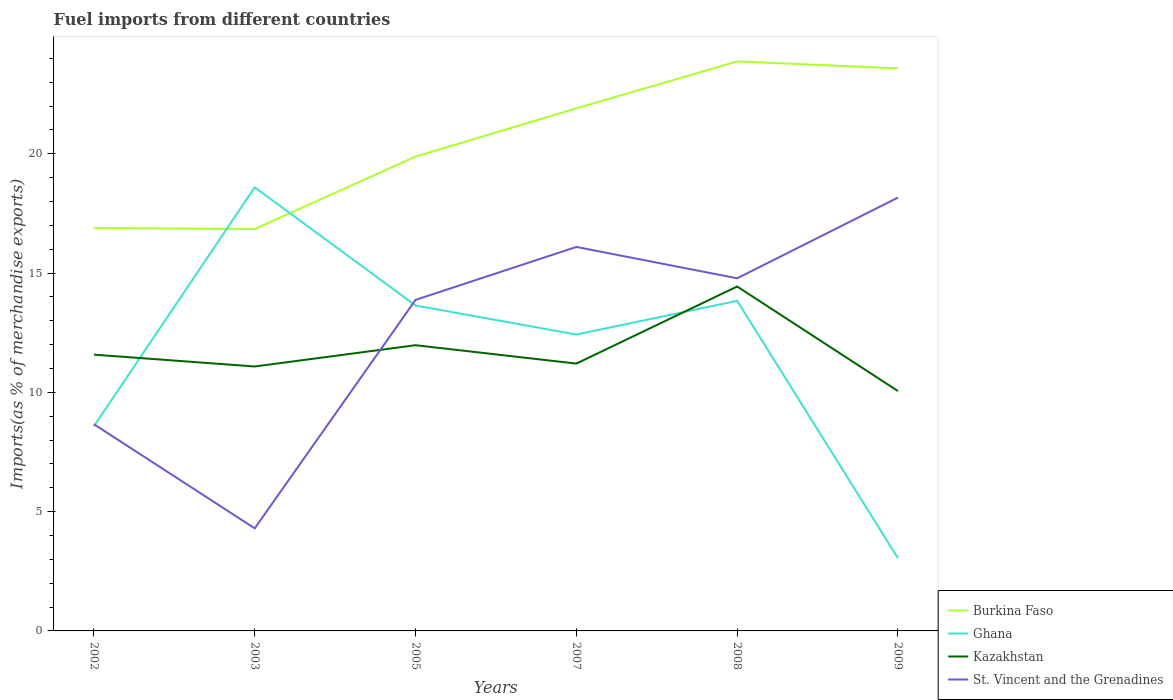Is the number of lines equal to the number of legend labels?
Give a very brief answer. Yes. Across all years, what is the maximum percentage of imports to different countries in St. Vincent and the Grenadines?
Provide a short and direct response. 4.3. In which year was the percentage of imports to different countries in Ghana maximum?
Provide a short and direct response. 2009. What is the total percentage of imports to different countries in Burkina Faso in the graph?
Your answer should be very brief. -6.73. What is the difference between the highest and the second highest percentage of imports to different countries in Burkina Faso?
Your answer should be very brief. 7.03. Is the percentage of imports to different countries in Kazakhstan strictly greater than the percentage of imports to different countries in Ghana over the years?
Give a very brief answer. No. What is the difference between two consecutive major ticks on the Y-axis?
Your answer should be compact. 5. Are the values on the major ticks of Y-axis written in scientific E-notation?
Offer a very short reply. No. Where does the legend appear in the graph?
Keep it short and to the point. Bottom right. How many legend labels are there?
Your response must be concise. 4. How are the legend labels stacked?
Your response must be concise. Vertical. What is the title of the graph?
Keep it short and to the point. Fuel imports from different countries. What is the label or title of the X-axis?
Give a very brief answer. Years. What is the label or title of the Y-axis?
Offer a terse response. Imports(as % of merchandise exports). What is the Imports(as % of merchandise exports) of Burkina Faso in 2002?
Give a very brief answer. 16.89. What is the Imports(as % of merchandise exports) in Ghana in 2002?
Your answer should be very brief. 8.58. What is the Imports(as % of merchandise exports) of Kazakhstan in 2002?
Your answer should be very brief. 11.58. What is the Imports(as % of merchandise exports) in St. Vincent and the Grenadines in 2002?
Provide a short and direct response. 8.67. What is the Imports(as % of merchandise exports) of Burkina Faso in 2003?
Make the answer very short. 16.85. What is the Imports(as % of merchandise exports) of Ghana in 2003?
Your answer should be compact. 18.6. What is the Imports(as % of merchandise exports) in Kazakhstan in 2003?
Make the answer very short. 11.09. What is the Imports(as % of merchandise exports) in St. Vincent and the Grenadines in 2003?
Provide a short and direct response. 4.3. What is the Imports(as % of merchandise exports) in Burkina Faso in 2005?
Your answer should be compact. 19.88. What is the Imports(as % of merchandise exports) of Ghana in 2005?
Give a very brief answer. 13.64. What is the Imports(as % of merchandise exports) in Kazakhstan in 2005?
Keep it short and to the point. 11.98. What is the Imports(as % of merchandise exports) of St. Vincent and the Grenadines in 2005?
Your response must be concise. 13.88. What is the Imports(as % of merchandise exports) of Burkina Faso in 2007?
Provide a short and direct response. 21.91. What is the Imports(as % of merchandise exports) in Ghana in 2007?
Offer a terse response. 12.43. What is the Imports(as % of merchandise exports) in Kazakhstan in 2007?
Make the answer very short. 11.21. What is the Imports(as % of merchandise exports) of St. Vincent and the Grenadines in 2007?
Your answer should be very brief. 16.1. What is the Imports(as % of merchandise exports) in Burkina Faso in 2008?
Make the answer very short. 23.87. What is the Imports(as % of merchandise exports) in Ghana in 2008?
Keep it short and to the point. 13.84. What is the Imports(as % of merchandise exports) of Kazakhstan in 2008?
Provide a succinct answer. 14.44. What is the Imports(as % of merchandise exports) of St. Vincent and the Grenadines in 2008?
Keep it short and to the point. 14.78. What is the Imports(as % of merchandise exports) in Burkina Faso in 2009?
Your answer should be very brief. 23.58. What is the Imports(as % of merchandise exports) in Ghana in 2009?
Ensure brevity in your answer.  3.05. What is the Imports(as % of merchandise exports) of Kazakhstan in 2009?
Provide a short and direct response. 10.06. What is the Imports(as % of merchandise exports) of St. Vincent and the Grenadines in 2009?
Give a very brief answer. 18.17. Across all years, what is the maximum Imports(as % of merchandise exports) in Burkina Faso?
Ensure brevity in your answer.  23.87. Across all years, what is the maximum Imports(as % of merchandise exports) of Ghana?
Provide a short and direct response. 18.6. Across all years, what is the maximum Imports(as % of merchandise exports) in Kazakhstan?
Give a very brief answer. 14.44. Across all years, what is the maximum Imports(as % of merchandise exports) of St. Vincent and the Grenadines?
Provide a short and direct response. 18.17. Across all years, what is the minimum Imports(as % of merchandise exports) in Burkina Faso?
Your answer should be very brief. 16.85. Across all years, what is the minimum Imports(as % of merchandise exports) of Ghana?
Offer a very short reply. 3.05. Across all years, what is the minimum Imports(as % of merchandise exports) in Kazakhstan?
Give a very brief answer. 10.06. Across all years, what is the minimum Imports(as % of merchandise exports) of St. Vincent and the Grenadines?
Your answer should be very brief. 4.3. What is the total Imports(as % of merchandise exports) in Burkina Faso in the graph?
Your response must be concise. 122.99. What is the total Imports(as % of merchandise exports) of Ghana in the graph?
Your answer should be compact. 70.13. What is the total Imports(as % of merchandise exports) of Kazakhstan in the graph?
Make the answer very short. 70.35. What is the total Imports(as % of merchandise exports) of St. Vincent and the Grenadines in the graph?
Give a very brief answer. 75.89. What is the difference between the Imports(as % of merchandise exports) of Burkina Faso in 2002 and that in 2003?
Your response must be concise. 0.04. What is the difference between the Imports(as % of merchandise exports) of Ghana in 2002 and that in 2003?
Keep it short and to the point. -10.01. What is the difference between the Imports(as % of merchandise exports) of Kazakhstan in 2002 and that in 2003?
Offer a very short reply. 0.5. What is the difference between the Imports(as % of merchandise exports) in St. Vincent and the Grenadines in 2002 and that in 2003?
Make the answer very short. 4.37. What is the difference between the Imports(as % of merchandise exports) in Burkina Faso in 2002 and that in 2005?
Ensure brevity in your answer.  -2.99. What is the difference between the Imports(as % of merchandise exports) in Ghana in 2002 and that in 2005?
Your answer should be very brief. -5.06. What is the difference between the Imports(as % of merchandise exports) of Kazakhstan in 2002 and that in 2005?
Provide a succinct answer. -0.4. What is the difference between the Imports(as % of merchandise exports) of St. Vincent and the Grenadines in 2002 and that in 2005?
Your response must be concise. -5.21. What is the difference between the Imports(as % of merchandise exports) of Burkina Faso in 2002 and that in 2007?
Your response must be concise. -5.02. What is the difference between the Imports(as % of merchandise exports) in Ghana in 2002 and that in 2007?
Keep it short and to the point. -3.84. What is the difference between the Imports(as % of merchandise exports) of Kazakhstan in 2002 and that in 2007?
Your answer should be compact. 0.38. What is the difference between the Imports(as % of merchandise exports) in St. Vincent and the Grenadines in 2002 and that in 2007?
Your response must be concise. -7.43. What is the difference between the Imports(as % of merchandise exports) in Burkina Faso in 2002 and that in 2008?
Offer a terse response. -6.98. What is the difference between the Imports(as % of merchandise exports) in Ghana in 2002 and that in 2008?
Keep it short and to the point. -5.26. What is the difference between the Imports(as % of merchandise exports) in Kazakhstan in 2002 and that in 2008?
Offer a very short reply. -2.86. What is the difference between the Imports(as % of merchandise exports) of St. Vincent and the Grenadines in 2002 and that in 2008?
Ensure brevity in your answer.  -6.12. What is the difference between the Imports(as % of merchandise exports) in Burkina Faso in 2002 and that in 2009?
Provide a succinct answer. -6.69. What is the difference between the Imports(as % of merchandise exports) of Ghana in 2002 and that in 2009?
Your answer should be compact. 5.53. What is the difference between the Imports(as % of merchandise exports) in Kazakhstan in 2002 and that in 2009?
Offer a terse response. 1.53. What is the difference between the Imports(as % of merchandise exports) of St. Vincent and the Grenadines in 2002 and that in 2009?
Offer a very short reply. -9.5. What is the difference between the Imports(as % of merchandise exports) of Burkina Faso in 2003 and that in 2005?
Your answer should be compact. -3.04. What is the difference between the Imports(as % of merchandise exports) of Ghana in 2003 and that in 2005?
Give a very brief answer. 4.95. What is the difference between the Imports(as % of merchandise exports) in Kazakhstan in 2003 and that in 2005?
Keep it short and to the point. -0.89. What is the difference between the Imports(as % of merchandise exports) in St. Vincent and the Grenadines in 2003 and that in 2005?
Offer a very short reply. -9.58. What is the difference between the Imports(as % of merchandise exports) of Burkina Faso in 2003 and that in 2007?
Provide a short and direct response. -5.06. What is the difference between the Imports(as % of merchandise exports) in Ghana in 2003 and that in 2007?
Provide a succinct answer. 6.17. What is the difference between the Imports(as % of merchandise exports) in Kazakhstan in 2003 and that in 2007?
Keep it short and to the point. -0.12. What is the difference between the Imports(as % of merchandise exports) in St. Vincent and the Grenadines in 2003 and that in 2007?
Provide a short and direct response. -11.8. What is the difference between the Imports(as % of merchandise exports) in Burkina Faso in 2003 and that in 2008?
Your answer should be compact. -7.03. What is the difference between the Imports(as % of merchandise exports) in Ghana in 2003 and that in 2008?
Provide a succinct answer. 4.76. What is the difference between the Imports(as % of merchandise exports) of Kazakhstan in 2003 and that in 2008?
Offer a terse response. -3.35. What is the difference between the Imports(as % of merchandise exports) in St. Vincent and the Grenadines in 2003 and that in 2008?
Make the answer very short. -10.48. What is the difference between the Imports(as % of merchandise exports) in Burkina Faso in 2003 and that in 2009?
Keep it short and to the point. -6.73. What is the difference between the Imports(as % of merchandise exports) of Ghana in 2003 and that in 2009?
Ensure brevity in your answer.  15.55. What is the difference between the Imports(as % of merchandise exports) in Kazakhstan in 2003 and that in 2009?
Make the answer very short. 1.03. What is the difference between the Imports(as % of merchandise exports) of St. Vincent and the Grenadines in 2003 and that in 2009?
Offer a very short reply. -13.87. What is the difference between the Imports(as % of merchandise exports) of Burkina Faso in 2005 and that in 2007?
Ensure brevity in your answer.  -2.02. What is the difference between the Imports(as % of merchandise exports) in Ghana in 2005 and that in 2007?
Make the answer very short. 1.22. What is the difference between the Imports(as % of merchandise exports) in Kazakhstan in 2005 and that in 2007?
Make the answer very short. 0.77. What is the difference between the Imports(as % of merchandise exports) in St. Vincent and the Grenadines in 2005 and that in 2007?
Provide a succinct answer. -2.22. What is the difference between the Imports(as % of merchandise exports) of Burkina Faso in 2005 and that in 2008?
Provide a short and direct response. -3.99. What is the difference between the Imports(as % of merchandise exports) of Ghana in 2005 and that in 2008?
Keep it short and to the point. -0.19. What is the difference between the Imports(as % of merchandise exports) of Kazakhstan in 2005 and that in 2008?
Ensure brevity in your answer.  -2.46. What is the difference between the Imports(as % of merchandise exports) of St. Vincent and the Grenadines in 2005 and that in 2008?
Keep it short and to the point. -0.91. What is the difference between the Imports(as % of merchandise exports) in Burkina Faso in 2005 and that in 2009?
Provide a short and direct response. -3.7. What is the difference between the Imports(as % of merchandise exports) in Ghana in 2005 and that in 2009?
Your answer should be very brief. 10.6. What is the difference between the Imports(as % of merchandise exports) in Kazakhstan in 2005 and that in 2009?
Ensure brevity in your answer.  1.92. What is the difference between the Imports(as % of merchandise exports) in St. Vincent and the Grenadines in 2005 and that in 2009?
Provide a succinct answer. -4.29. What is the difference between the Imports(as % of merchandise exports) of Burkina Faso in 2007 and that in 2008?
Keep it short and to the point. -1.97. What is the difference between the Imports(as % of merchandise exports) in Ghana in 2007 and that in 2008?
Make the answer very short. -1.41. What is the difference between the Imports(as % of merchandise exports) in Kazakhstan in 2007 and that in 2008?
Give a very brief answer. -3.23. What is the difference between the Imports(as % of merchandise exports) of St. Vincent and the Grenadines in 2007 and that in 2008?
Your response must be concise. 1.31. What is the difference between the Imports(as % of merchandise exports) of Burkina Faso in 2007 and that in 2009?
Provide a short and direct response. -1.68. What is the difference between the Imports(as % of merchandise exports) of Ghana in 2007 and that in 2009?
Make the answer very short. 9.38. What is the difference between the Imports(as % of merchandise exports) of Kazakhstan in 2007 and that in 2009?
Make the answer very short. 1.15. What is the difference between the Imports(as % of merchandise exports) in St. Vincent and the Grenadines in 2007 and that in 2009?
Provide a succinct answer. -2.07. What is the difference between the Imports(as % of merchandise exports) of Burkina Faso in 2008 and that in 2009?
Your answer should be very brief. 0.29. What is the difference between the Imports(as % of merchandise exports) of Ghana in 2008 and that in 2009?
Offer a very short reply. 10.79. What is the difference between the Imports(as % of merchandise exports) in Kazakhstan in 2008 and that in 2009?
Keep it short and to the point. 4.38. What is the difference between the Imports(as % of merchandise exports) of St. Vincent and the Grenadines in 2008 and that in 2009?
Provide a succinct answer. -3.38. What is the difference between the Imports(as % of merchandise exports) of Burkina Faso in 2002 and the Imports(as % of merchandise exports) of Ghana in 2003?
Offer a very short reply. -1.71. What is the difference between the Imports(as % of merchandise exports) of Burkina Faso in 2002 and the Imports(as % of merchandise exports) of Kazakhstan in 2003?
Provide a short and direct response. 5.8. What is the difference between the Imports(as % of merchandise exports) of Burkina Faso in 2002 and the Imports(as % of merchandise exports) of St. Vincent and the Grenadines in 2003?
Make the answer very short. 12.59. What is the difference between the Imports(as % of merchandise exports) in Ghana in 2002 and the Imports(as % of merchandise exports) in Kazakhstan in 2003?
Give a very brief answer. -2.5. What is the difference between the Imports(as % of merchandise exports) of Ghana in 2002 and the Imports(as % of merchandise exports) of St. Vincent and the Grenadines in 2003?
Make the answer very short. 4.28. What is the difference between the Imports(as % of merchandise exports) in Kazakhstan in 2002 and the Imports(as % of merchandise exports) in St. Vincent and the Grenadines in 2003?
Your response must be concise. 7.28. What is the difference between the Imports(as % of merchandise exports) of Burkina Faso in 2002 and the Imports(as % of merchandise exports) of Ghana in 2005?
Offer a very short reply. 3.25. What is the difference between the Imports(as % of merchandise exports) in Burkina Faso in 2002 and the Imports(as % of merchandise exports) in Kazakhstan in 2005?
Offer a very short reply. 4.91. What is the difference between the Imports(as % of merchandise exports) in Burkina Faso in 2002 and the Imports(as % of merchandise exports) in St. Vincent and the Grenadines in 2005?
Make the answer very short. 3.01. What is the difference between the Imports(as % of merchandise exports) in Ghana in 2002 and the Imports(as % of merchandise exports) in Kazakhstan in 2005?
Offer a terse response. -3.4. What is the difference between the Imports(as % of merchandise exports) in Ghana in 2002 and the Imports(as % of merchandise exports) in St. Vincent and the Grenadines in 2005?
Make the answer very short. -5.3. What is the difference between the Imports(as % of merchandise exports) of Kazakhstan in 2002 and the Imports(as % of merchandise exports) of St. Vincent and the Grenadines in 2005?
Your response must be concise. -2.29. What is the difference between the Imports(as % of merchandise exports) of Burkina Faso in 2002 and the Imports(as % of merchandise exports) of Ghana in 2007?
Offer a terse response. 4.47. What is the difference between the Imports(as % of merchandise exports) of Burkina Faso in 2002 and the Imports(as % of merchandise exports) of Kazakhstan in 2007?
Keep it short and to the point. 5.68. What is the difference between the Imports(as % of merchandise exports) of Burkina Faso in 2002 and the Imports(as % of merchandise exports) of St. Vincent and the Grenadines in 2007?
Provide a succinct answer. 0.79. What is the difference between the Imports(as % of merchandise exports) in Ghana in 2002 and the Imports(as % of merchandise exports) in Kazakhstan in 2007?
Give a very brief answer. -2.63. What is the difference between the Imports(as % of merchandise exports) of Ghana in 2002 and the Imports(as % of merchandise exports) of St. Vincent and the Grenadines in 2007?
Your answer should be very brief. -7.52. What is the difference between the Imports(as % of merchandise exports) in Kazakhstan in 2002 and the Imports(as % of merchandise exports) in St. Vincent and the Grenadines in 2007?
Keep it short and to the point. -4.51. What is the difference between the Imports(as % of merchandise exports) in Burkina Faso in 2002 and the Imports(as % of merchandise exports) in Ghana in 2008?
Provide a short and direct response. 3.05. What is the difference between the Imports(as % of merchandise exports) in Burkina Faso in 2002 and the Imports(as % of merchandise exports) in Kazakhstan in 2008?
Keep it short and to the point. 2.45. What is the difference between the Imports(as % of merchandise exports) in Burkina Faso in 2002 and the Imports(as % of merchandise exports) in St. Vincent and the Grenadines in 2008?
Ensure brevity in your answer.  2.11. What is the difference between the Imports(as % of merchandise exports) in Ghana in 2002 and the Imports(as % of merchandise exports) in Kazakhstan in 2008?
Provide a short and direct response. -5.86. What is the difference between the Imports(as % of merchandise exports) of Ghana in 2002 and the Imports(as % of merchandise exports) of St. Vincent and the Grenadines in 2008?
Keep it short and to the point. -6.2. What is the difference between the Imports(as % of merchandise exports) of Kazakhstan in 2002 and the Imports(as % of merchandise exports) of St. Vincent and the Grenadines in 2008?
Offer a terse response. -3.2. What is the difference between the Imports(as % of merchandise exports) of Burkina Faso in 2002 and the Imports(as % of merchandise exports) of Ghana in 2009?
Offer a terse response. 13.84. What is the difference between the Imports(as % of merchandise exports) in Burkina Faso in 2002 and the Imports(as % of merchandise exports) in Kazakhstan in 2009?
Ensure brevity in your answer.  6.83. What is the difference between the Imports(as % of merchandise exports) in Burkina Faso in 2002 and the Imports(as % of merchandise exports) in St. Vincent and the Grenadines in 2009?
Provide a succinct answer. -1.28. What is the difference between the Imports(as % of merchandise exports) in Ghana in 2002 and the Imports(as % of merchandise exports) in Kazakhstan in 2009?
Make the answer very short. -1.47. What is the difference between the Imports(as % of merchandise exports) in Ghana in 2002 and the Imports(as % of merchandise exports) in St. Vincent and the Grenadines in 2009?
Your answer should be very brief. -9.58. What is the difference between the Imports(as % of merchandise exports) in Kazakhstan in 2002 and the Imports(as % of merchandise exports) in St. Vincent and the Grenadines in 2009?
Provide a short and direct response. -6.58. What is the difference between the Imports(as % of merchandise exports) in Burkina Faso in 2003 and the Imports(as % of merchandise exports) in Ghana in 2005?
Your answer should be compact. 3.21. What is the difference between the Imports(as % of merchandise exports) of Burkina Faso in 2003 and the Imports(as % of merchandise exports) of Kazakhstan in 2005?
Your answer should be compact. 4.87. What is the difference between the Imports(as % of merchandise exports) of Burkina Faso in 2003 and the Imports(as % of merchandise exports) of St. Vincent and the Grenadines in 2005?
Offer a very short reply. 2.97. What is the difference between the Imports(as % of merchandise exports) in Ghana in 2003 and the Imports(as % of merchandise exports) in Kazakhstan in 2005?
Offer a terse response. 6.62. What is the difference between the Imports(as % of merchandise exports) of Ghana in 2003 and the Imports(as % of merchandise exports) of St. Vincent and the Grenadines in 2005?
Ensure brevity in your answer.  4.72. What is the difference between the Imports(as % of merchandise exports) in Kazakhstan in 2003 and the Imports(as % of merchandise exports) in St. Vincent and the Grenadines in 2005?
Your response must be concise. -2.79. What is the difference between the Imports(as % of merchandise exports) of Burkina Faso in 2003 and the Imports(as % of merchandise exports) of Ghana in 2007?
Make the answer very short. 4.42. What is the difference between the Imports(as % of merchandise exports) of Burkina Faso in 2003 and the Imports(as % of merchandise exports) of Kazakhstan in 2007?
Your answer should be compact. 5.64. What is the difference between the Imports(as % of merchandise exports) of Burkina Faso in 2003 and the Imports(as % of merchandise exports) of St. Vincent and the Grenadines in 2007?
Ensure brevity in your answer.  0.75. What is the difference between the Imports(as % of merchandise exports) of Ghana in 2003 and the Imports(as % of merchandise exports) of Kazakhstan in 2007?
Ensure brevity in your answer.  7.39. What is the difference between the Imports(as % of merchandise exports) in Ghana in 2003 and the Imports(as % of merchandise exports) in St. Vincent and the Grenadines in 2007?
Your answer should be very brief. 2.5. What is the difference between the Imports(as % of merchandise exports) of Kazakhstan in 2003 and the Imports(as % of merchandise exports) of St. Vincent and the Grenadines in 2007?
Ensure brevity in your answer.  -5.01. What is the difference between the Imports(as % of merchandise exports) of Burkina Faso in 2003 and the Imports(as % of merchandise exports) of Ghana in 2008?
Ensure brevity in your answer.  3.01. What is the difference between the Imports(as % of merchandise exports) of Burkina Faso in 2003 and the Imports(as % of merchandise exports) of Kazakhstan in 2008?
Your answer should be very brief. 2.41. What is the difference between the Imports(as % of merchandise exports) of Burkina Faso in 2003 and the Imports(as % of merchandise exports) of St. Vincent and the Grenadines in 2008?
Offer a terse response. 2.07. What is the difference between the Imports(as % of merchandise exports) in Ghana in 2003 and the Imports(as % of merchandise exports) in Kazakhstan in 2008?
Provide a succinct answer. 4.16. What is the difference between the Imports(as % of merchandise exports) of Ghana in 2003 and the Imports(as % of merchandise exports) of St. Vincent and the Grenadines in 2008?
Your answer should be compact. 3.81. What is the difference between the Imports(as % of merchandise exports) of Kazakhstan in 2003 and the Imports(as % of merchandise exports) of St. Vincent and the Grenadines in 2008?
Ensure brevity in your answer.  -3.7. What is the difference between the Imports(as % of merchandise exports) of Burkina Faso in 2003 and the Imports(as % of merchandise exports) of Ghana in 2009?
Offer a terse response. 13.8. What is the difference between the Imports(as % of merchandise exports) of Burkina Faso in 2003 and the Imports(as % of merchandise exports) of Kazakhstan in 2009?
Provide a short and direct response. 6.79. What is the difference between the Imports(as % of merchandise exports) in Burkina Faso in 2003 and the Imports(as % of merchandise exports) in St. Vincent and the Grenadines in 2009?
Give a very brief answer. -1.32. What is the difference between the Imports(as % of merchandise exports) in Ghana in 2003 and the Imports(as % of merchandise exports) in Kazakhstan in 2009?
Offer a terse response. 8.54. What is the difference between the Imports(as % of merchandise exports) of Ghana in 2003 and the Imports(as % of merchandise exports) of St. Vincent and the Grenadines in 2009?
Provide a short and direct response. 0.43. What is the difference between the Imports(as % of merchandise exports) of Kazakhstan in 2003 and the Imports(as % of merchandise exports) of St. Vincent and the Grenadines in 2009?
Offer a very short reply. -7.08. What is the difference between the Imports(as % of merchandise exports) of Burkina Faso in 2005 and the Imports(as % of merchandise exports) of Ghana in 2007?
Keep it short and to the point. 7.46. What is the difference between the Imports(as % of merchandise exports) in Burkina Faso in 2005 and the Imports(as % of merchandise exports) in Kazakhstan in 2007?
Provide a short and direct response. 8.68. What is the difference between the Imports(as % of merchandise exports) in Burkina Faso in 2005 and the Imports(as % of merchandise exports) in St. Vincent and the Grenadines in 2007?
Offer a terse response. 3.79. What is the difference between the Imports(as % of merchandise exports) in Ghana in 2005 and the Imports(as % of merchandise exports) in Kazakhstan in 2007?
Provide a succinct answer. 2.44. What is the difference between the Imports(as % of merchandise exports) in Ghana in 2005 and the Imports(as % of merchandise exports) in St. Vincent and the Grenadines in 2007?
Offer a very short reply. -2.45. What is the difference between the Imports(as % of merchandise exports) in Kazakhstan in 2005 and the Imports(as % of merchandise exports) in St. Vincent and the Grenadines in 2007?
Provide a succinct answer. -4.12. What is the difference between the Imports(as % of merchandise exports) in Burkina Faso in 2005 and the Imports(as % of merchandise exports) in Ghana in 2008?
Give a very brief answer. 6.05. What is the difference between the Imports(as % of merchandise exports) of Burkina Faso in 2005 and the Imports(as % of merchandise exports) of Kazakhstan in 2008?
Your response must be concise. 5.45. What is the difference between the Imports(as % of merchandise exports) in Burkina Faso in 2005 and the Imports(as % of merchandise exports) in St. Vincent and the Grenadines in 2008?
Keep it short and to the point. 5.1. What is the difference between the Imports(as % of merchandise exports) of Ghana in 2005 and the Imports(as % of merchandise exports) of Kazakhstan in 2008?
Your answer should be compact. -0.8. What is the difference between the Imports(as % of merchandise exports) of Ghana in 2005 and the Imports(as % of merchandise exports) of St. Vincent and the Grenadines in 2008?
Your answer should be very brief. -1.14. What is the difference between the Imports(as % of merchandise exports) of Kazakhstan in 2005 and the Imports(as % of merchandise exports) of St. Vincent and the Grenadines in 2008?
Offer a terse response. -2.81. What is the difference between the Imports(as % of merchandise exports) of Burkina Faso in 2005 and the Imports(as % of merchandise exports) of Ghana in 2009?
Ensure brevity in your answer.  16.84. What is the difference between the Imports(as % of merchandise exports) in Burkina Faso in 2005 and the Imports(as % of merchandise exports) in Kazakhstan in 2009?
Your response must be concise. 9.83. What is the difference between the Imports(as % of merchandise exports) in Burkina Faso in 2005 and the Imports(as % of merchandise exports) in St. Vincent and the Grenadines in 2009?
Offer a terse response. 1.72. What is the difference between the Imports(as % of merchandise exports) in Ghana in 2005 and the Imports(as % of merchandise exports) in Kazakhstan in 2009?
Offer a terse response. 3.59. What is the difference between the Imports(as % of merchandise exports) of Ghana in 2005 and the Imports(as % of merchandise exports) of St. Vincent and the Grenadines in 2009?
Offer a terse response. -4.52. What is the difference between the Imports(as % of merchandise exports) of Kazakhstan in 2005 and the Imports(as % of merchandise exports) of St. Vincent and the Grenadines in 2009?
Your answer should be compact. -6.19. What is the difference between the Imports(as % of merchandise exports) in Burkina Faso in 2007 and the Imports(as % of merchandise exports) in Ghana in 2008?
Your answer should be very brief. 8.07. What is the difference between the Imports(as % of merchandise exports) in Burkina Faso in 2007 and the Imports(as % of merchandise exports) in Kazakhstan in 2008?
Keep it short and to the point. 7.47. What is the difference between the Imports(as % of merchandise exports) of Burkina Faso in 2007 and the Imports(as % of merchandise exports) of St. Vincent and the Grenadines in 2008?
Give a very brief answer. 7.12. What is the difference between the Imports(as % of merchandise exports) of Ghana in 2007 and the Imports(as % of merchandise exports) of Kazakhstan in 2008?
Ensure brevity in your answer.  -2.01. What is the difference between the Imports(as % of merchandise exports) of Ghana in 2007 and the Imports(as % of merchandise exports) of St. Vincent and the Grenadines in 2008?
Provide a succinct answer. -2.36. What is the difference between the Imports(as % of merchandise exports) in Kazakhstan in 2007 and the Imports(as % of merchandise exports) in St. Vincent and the Grenadines in 2008?
Offer a terse response. -3.58. What is the difference between the Imports(as % of merchandise exports) in Burkina Faso in 2007 and the Imports(as % of merchandise exports) in Ghana in 2009?
Offer a very short reply. 18.86. What is the difference between the Imports(as % of merchandise exports) of Burkina Faso in 2007 and the Imports(as % of merchandise exports) of Kazakhstan in 2009?
Your answer should be very brief. 11.85. What is the difference between the Imports(as % of merchandise exports) of Burkina Faso in 2007 and the Imports(as % of merchandise exports) of St. Vincent and the Grenadines in 2009?
Ensure brevity in your answer.  3.74. What is the difference between the Imports(as % of merchandise exports) in Ghana in 2007 and the Imports(as % of merchandise exports) in Kazakhstan in 2009?
Make the answer very short. 2.37. What is the difference between the Imports(as % of merchandise exports) in Ghana in 2007 and the Imports(as % of merchandise exports) in St. Vincent and the Grenadines in 2009?
Keep it short and to the point. -5.74. What is the difference between the Imports(as % of merchandise exports) in Kazakhstan in 2007 and the Imports(as % of merchandise exports) in St. Vincent and the Grenadines in 2009?
Provide a succinct answer. -6.96. What is the difference between the Imports(as % of merchandise exports) in Burkina Faso in 2008 and the Imports(as % of merchandise exports) in Ghana in 2009?
Give a very brief answer. 20.83. What is the difference between the Imports(as % of merchandise exports) of Burkina Faso in 2008 and the Imports(as % of merchandise exports) of Kazakhstan in 2009?
Your answer should be very brief. 13.82. What is the difference between the Imports(as % of merchandise exports) in Burkina Faso in 2008 and the Imports(as % of merchandise exports) in St. Vincent and the Grenadines in 2009?
Give a very brief answer. 5.71. What is the difference between the Imports(as % of merchandise exports) in Ghana in 2008 and the Imports(as % of merchandise exports) in Kazakhstan in 2009?
Your response must be concise. 3.78. What is the difference between the Imports(as % of merchandise exports) in Ghana in 2008 and the Imports(as % of merchandise exports) in St. Vincent and the Grenadines in 2009?
Keep it short and to the point. -4.33. What is the difference between the Imports(as % of merchandise exports) of Kazakhstan in 2008 and the Imports(as % of merchandise exports) of St. Vincent and the Grenadines in 2009?
Give a very brief answer. -3.73. What is the average Imports(as % of merchandise exports) in Burkina Faso per year?
Keep it short and to the point. 20.5. What is the average Imports(as % of merchandise exports) in Ghana per year?
Your response must be concise. 11.69. What is the average Imports(as % of merchandise exports) in Kazakhstan per year?
Provide a short and direct response. 11.72. What is the average Imports(as % of merchandise exports) in St. Vincent and the Grenadines per year?
Give a very brief answer. 12.65. In the year 2002, what is the difference between the Imports(as % of merchandise exports) of Burkina Faso and Imports(as % of merchandise exports) of Ghana?
Provide a succinct answer. 8.31. In the year 2002, what is the difference between the Imports(as % of merchandise exports) in Burkina Faso and Imports(as % of merchandise exports) in Kazakhstan?
Offer a very short reply. 5.31. In the year 2002, what is the difference between the Imports(as % of merchandise exports) of Burkina Faso and Imports(as % of merchandise exports) of St. Vincent and the Grenadines?
Your answer should be compact. 8.23. In the year 2002, what is the difference between the Imports(as % of merchandise exports) of Ghana and Imports(as % of merchandise exports) of Kazakhstan?
Your answer should be compact. -3. In the year 2002, what is the difference between the Imports(as % of merchandise exports) of Ghana and Imports(as % of merchandise exports) of St. Vincent and the Grenadines?
Give a very brief answer. -0.08. In the year 2002, what is the difference between the Imports(as % of merchandise exports) of Kazakhstan and Imports(as % of merchandise exports) of St. Vincent and the Grenadines?
Provide a short and direct response. 2.92. In the year 2003, what is the difference between the Imports(as % of merchandise exports) in Burkina Faso and Imports(as % of merchandise exports) in Ghana?
Keep it short and to the point. -1.75. In the year 2003, what is the difference between the Imports(as % of merchandise exports) of Burkina Faso and Imports(as % of merchandise exports) of Kazakhstan?
Ensure brevity in your answer.  5.76. In the year 2003, what is the difference between the Imports(as % of merchandise exports) in Burkina Faso and Imports(as % of merchandise exports) in St. Vincent and the Grenadines?
Provide a short and direct response. 12.55. In the year 2003, what is the difference between the Imports(as % of merchandise exports) of Ghana and Imports(as % of merchandise exports) of Kazakhstan?
Keep it short and to the point. 7.51. In the year 2003, what is the difference between the Imports(as % of merchandise exports) in Ghana and Imports(as % of merchandise exports) in St. Vincent and the Grenadines?
Your response must be concise. 14.3. In the year 2003, what is the difference between the Imports(as % of merchandise exports) of Kazakhstan and Imports(as % of merchandise exports) of St. Vincent and the Grenadines?
Ensure brevity in your answer.  6.79. In the year 2005, what is the difference between the Imports(as % of merchandise exports) in Burkina Faso and Imports(as % of merchandise exports) in Ghana?
Offer a terse response. 6.24. In the year 2005, what is the difference between the Imports(as % of merchandise exports) in Burkina Faso and Imports(as % of merchandise exports) in Kazakhstan?
Your answer should be very brief. 7.91. In the year 2005, what is the difference between the Imports(as % of merchandise exports) of Burkina Faso and Imports(as % of merchandise exports) of St. Vincent and the Grenadines?
Your response must be concise. 6.01. In the year 2005, what is the difference between the Imports(as % of merchandise exports) in Ghana and Imports(as % of merchandise exports) in Kazakhstan?
Ensure brevity in your answer.  1.67. In the year 2005, what is the difference between the Imports(as % of merchandise exports) of Ghana and Imports(as % of merchandise exports) of St. Vincent and the Grenadines?
Make the answer very short. -0.23. In the year 2005, what is the difference between the Imports(as % of merchandise exports) of Kazakhstan and Imports(as % of merchandise exports) of St. Vincent and the Grenadines?
Give a very brief answer. -1.9. In the year 2007, what is the difference between the Imports(as % of merchandise exports) in Burkina Faso and Imports(as % of merchandise exports) in Ghana?
Your answer should be very brief. 9.48. In the year 2007, what is the difference between the Imports(as % of merchandise exports) of Burkina Faso and Imports(as % of merchandise exports) of Kazakhstan?
Offer a very short reply. 10.7. In the year 2007, what is the difference between the Imports(as % of merchandise exports) in Burkina Faso and Imports(as % of merchandise exports) in St. Vincent and the Grenadines?
Ensure brevity in your answer.  5.81. In the year 2007, what is the difference between the Imports(as % of merchandise exports) in Ghana and Imports(as % of merchandise exports) in Kazakhstan?
Ensure brevity in your answer.  1.22. In the year 2007, what is the difference between the Imports(as % of merchandise exports) of Ghana and Imports(as % of merchandise exports) of St. Vincent and the Grenadines?
Offer a terse response. -3.67. In the year 2007, what is the difference between the Imports(as % of merchandise exports) in Kazakhstan and Imports(as % of merchandise exports) in St. Vincent and the Grenadines?
Your answer should be very brief. -4.89. In the year 2008, what is the difference between the Imports(as % of merchandise exports) in Burkina Faso and Imports(as % of merchandise exports) in Ghana?
Provide a short and direct response. 10.04. In the year 2008, what is the difference between the Imports(as % of merchandise exports) of Burkina Faso and Imports(as % of merchandise exports) of Kazakhstan?
Provide a succinct answer. 9.44. In the year 2008, what is the difference between the Imports(as % of merchandise exports) of Burkina Faso and Imports(as % of merchandise exports) of St. Vincent and the Grenadines?
Keep it short and to the point. 9.09. In the year 2008, what is the difference between the Imports(as % of merchandise exports) in Ghana and Imports(as % of merchandise exports) in Kazakhstan?
Your answer should be very brief. -0.6. In the year 2008, what is the difference between the Imports(as % of merchandise exports) of Ghana and Imports(as % of merchandise exports) of St. Vincent and the Grenadines?
Offer a terse response. -0.95. In the year 2008, what is the difference between the Imports(as % of merchandise exports) in Kazakhstan and Imports(as % of merchandise exports) in St. Vincent and the Grenadines?
Ensure brevity in your answer.  -0.34. In the year 2009, what is the difference between the Imports(as % of merchandise exports) in Burkina Faso and Imports(as % of merchandise exports) in Ghana?
Provide a succinct answer. 20.54. In the year 2009, what is the difference between the Imports(as % of merchandise exports) of Burkina Faso and Imports(as % of merchandise exports) of Kazakhstan?
Provide a succinct answer. 13.53. In the year 2009, what is the difference between the Imports(as % of merchandise exports) in Burkina Faso and Imports(as % of merchandise exports) in St. Vincent and the Grenadines?
Provide a short and direct response. 5.42. In the year 2009, what is the difference between the Imports(as % of merchandise exports) of Ghana and Imports(as % of merchandise exports) of Kazakhstan?
Ensure brevity in your answer.  -7.01. In the year 2009, what is the difference between the Imports(as % of merchandise exports) of Ghana and Imports(as % of merchandise exports) of St. Vincent and the Grenadines?
Keep it short and to the point. -15.12. In the year 2009, what is the difference between the Imports(as % of merchandise exports) in Kazakhstan and Imports(as % of merchandise exports) in St. Vincent and the Grenadines?
Your answer should be compact. -8.11. What is the ratio of the Imports(as % of merchandise exports) of Ghana in 2002 to that in 2003?
Make the answer very short. 0.46. What is the ratio of the Imports(as % of merchandise exports) in Kazakhstan in 2002 to that in 2003?
Provide a short and direct response. 1.04. What is the ratio of the Imports(as % of merchandise exports) of St. Vincent and the Grenadines in 2002 to that in 2003?
Your answer should be compact. 2.02. What is the ratio of the Imports(as % of merchandise exports) in Burkina Faso in 2002 to that in 2005?
Your answer should be compact. 0.85. What is the ratio of the Imports(as % of merchandise exports) of Ghana in 2002 to that in 2005?
Your answer should be very brief. 0.63. What is the ratio of the Imports(as % of merchandise exports) in St. Vincent and the Grenadines in 2002 to that in 2005?
Keep it short and to the point. 0.62. What is the ratio of the Imports(as % of merchandise exports) of Burkina Faso in 2002 to that in 2007?
Offer a terse response. 0.77. What is the ratio of the Imports(as % of merchandise exports) in Ghana in 2002 to that in 2007?
Give a very brief answer. 0.69. What is the ratio of the Imports(as % of merchandise exports) in Kazakhstan in 2002 to that in 2007?
Give a very brief answer. 1.03. What is the ratio of the Imports(as % of merchandise exports) of St. Vincent and the Grenadines in 2002 to that in 2007?
Keep it short and to the point. 0.54. What is the ratio of the Imports(as % of merchandise exports) of Burkina Faso in 2002 to that in 2008?
Provide a succinct answer. 0.71. What is the ratio of the Imports(as % of merchandise exports) in Ghana in 2002 to that in 2008?
Your response must be concise. 0.62. What is the ratio of the Imports(as % of merchandise exports) of Kazakhstan in 2002 to that in 2008?
Give a very brief answer. 0.8. What is the ratio of the Imports(as % of merchandise exports) in St. Vincent and the Grenadines in 2002 to that in 2008?
Offer a very short reply. 0.59. What is the ratio of the Imports(as % of merchandise exports) of Burkina Faso in 2002 to that in 2009?
Your answer should be compact. 0.72. What is the ratio of the Imports(as % of merchandise exports) of Ghana in 2002 to that in 2009?
Your response must be concise. 2.82. What is the ratio of the Imports(as % of merchandise exports) in Kazakhstan in 2002 to that in 2009?
Your answer should be very brief. 1.15. What is the ratio of the Imports(as % of merchandise exports) in St. Vincent and the Grenadines in 2002 to that in 2009?
Provide a short and direct response. 0.48. What is the ratio of the Imports(as % of merchandise exports) in Burkina Faso in 2003 to that in 2005?
Offer a very short reply. 0.85. What is the ratio of the Imports(as % of merchandise exports) of Ghana in 2003 to that in 2005?
Your answer should be compact. 1.36. What is the ratio of the Imports(as % of merchandise exports) in Kazakhstan in 2003 to that in 2005?
Provide a succinct answer. 0.93. What is the ratio of the Imports(as % of merchandise exports) of St. Vincent and the Grenadines in 2003 to that in 2005?
Your answer should be compact. 0.31. What is the ratio of the Imports(as % of merchandise exports) of Burkina Faso in 2003 to that in 2007?
Provide a succinct answer. 0.77. What is the ratio of the Imports(as % of merchandise exports) in Ghana in 2003 to that in 2007?
Give a very brief answer. 1.5. What is the ratio of the Imports(as % of merchandise exports) in St. Vincent and the Grenadines in 2003 to that in 2007?
Offer a very short reply. 0.27. What is the ratio of the Imports(as % of merchandise exports) in Burkina Faso in 2003 to that in 2008?
Keep it short and to the point. 0.71. What is the ratio of the Imports(as % of merchandise exports) in Ghana in 2003 to that in 2008?
Keep it short and to the point. 1.34. What is the ratio of the Imports(as % of merchandise exports) in Kazakhstan in 2003 to that in 2008?
Provide a short and direct response. 0.77. What is the ratio of the Imports(as % of merchandise exports) of St. Vincent and the Grenadines in 2003 to that in 2008?
Your answer should be compact. 0.29. What is the ratio of the Imports(as % of merchandise exports) of Burkina Faso in 2003 to that in 2009?
Your response must be concise. 0.71. What is the ratio of the Imports(as % of merchandise exports) of Ghana in 2003 to that in 2009?
Make the answer very short. 6.1. What is the ratio of the Imports(as % of merchandise exports) in Kazakhstan in 2003 to that in 2009?
Give a very brief answer. 1.1. What is the ratio of the Imports(as % of merchandise exports) of St. Vincent and the Grenadines in 2003 to that in 2009?
Offer a terse response. 0.24. What is the ratio of the Imports(as % of merchandise exports) of Burkina Faso in 2005 to that in 2007?
Ensure brevity in your answer.  0.91. What is the ratio of the Imports(as % of merchandise exports) of Ghana in 2005 to that in 2007?
Provide a succinct answer. 1.1. What is the ratio of the Imports(as % of merchandise exports) in Kazakhstan in 2005 to that in 2007?
Your answer should be very brief. 1.07. What is the ratio of the Imports(as % of merchandise exports) in St. Vincent and the Grenadines in 2005 to that in 2007?
Give a very brief answer. 0.86. What is the ratio of the Imports(as % of merchandise exports) of Burkina Faso in 2005 to that in 2008?
Your response must be concise. 0.83. What is the ratio of the Imports(as % of merchandise exports) in Ghana in 2005 to that in 2008?
Ensure brevity in your answer.  0.99. What is the ratio of the Imports(as % of merchandise exports) in Kazakhstan in 2005 to that in 2008?
Make the answer very short. 0.83. What is the ratio of the Imports(as % of merchandise exports) in St. Vincent and the Grenadines in 2005 to that in 2008?
Your response must be concise. 0.94. What is the ratio of the Imports(as % of merchandise exports) of Burkina Faso in 2005 to that in 2009?
Your response must be concise. 0.84. What is the ratio of the Imports(as % of merchandise exports) of Ghana in 2005 to that in 2009?
Keep it short and to the point. 4.48. What is the ratio of the Imports(as % of merchandise exports) of Kazakhstan in 2005 to that in 2009?
Your answer should be compact. 1.19. What is the ratio of the Imports(as % of merchandise exports) in St. Vincent and the Grenadines in 2005 to that in 2009?
Provide a short and direct response. 0.76. What is the ratio of the Imports(as % of merchandise exports) of Burkina Faso in 2007 to that in 2008?
Your answer should be very brief. 0.92. What is the ratio of the Imports(as % of merchandise exports) of Ghana in 2007 to that in 2008?
Give a very brief answer. 0.9. What is the ratio of the Imports(as % of merchandise exports) in Kazakhstan in 2007 to that in 2008?
Offer a very short reply. 0.78. What is the ratio of the Imports(as % of merchandise exports) in St. Vincent and the Grenadines in 2007 to that in 2008?
Keep it short and to the point. 1.09. What is the ratio of the Imports(as % of merchandise exports) of Burkina Faso in 2007 to that in 2009?
Your answer should be compact. 0.93. What is the ratio of the Imports(as % of merchandise exports) in Ghana in 2007 to that in 2009?
Keep it short and to the point. 4.08. What is the ratio of the Imports(as % of merchandise exports) in Kazakhstan in 2007 to that in 2009?
Offer a terse response. 1.11. What is the ratio of the Imports(as % of merchandise exports) in St. Vincent and the Grenadines in 2007 to that in 2009?
Offer a very short reply. 0.89. What is the ratio of the Imports(as % of merchandise exports) of Burkina Faso in 2008 to that in 2009?
Ensure brevity in your answer.  1.01. What is the ratio of the Imports(as % of merchandise exports) of Ghana in 2008 to that in 2009?
Keep it short and to the point. 4.54. What is the ratio of the Imports(as % of merchandise exports) in Kazakhstan in 2008 to that in 2009?
Make the answer very short. 1.44. What is the ratio of the Imports(as % of merchandise exports) of St. Vincent and the Grenadines in 2008 to that in 2009?
Your response must be concise. 0.81. What is the difference between the highest and the second highest Imports(as % of merchandise exports) of Burkina Faso?
Offer a terse response. 0.29. What is the difference between the highest and the second highest Imports(as % of merchandise exports) of Ghana?
Make the answer very short. 4.76. What is the difference between the highest and the second highest Imports(as % of merchandise exports) of Kazakhstan?
Your response must be concise. 2.46. What is the difference between the highest and the second highest Imports(as % of merchandise exports) of St. Vincent and the Grenadines?
Make the answer very short. 2.07. What is the difference between the highest and the lowest Imports(as % of merchandise exports) in Burkina Faso?
Your answer should be very brief. 7.03. What is the difference between the highest and the lowest Imports(as % of merchandise exports) of Ghana?
Keep it short and to the point. 15.55. What is the difference between the highest and the lowest Imports(as % of merchandise exports) of Kazakhstan?
Your answer should be very brief. 4.38. What is the difference between the highest and the lowest Imports(as % of merchandise exports) in St. Vincent and the Grenadines?
Ensure brevity in your answer.  13.87. 